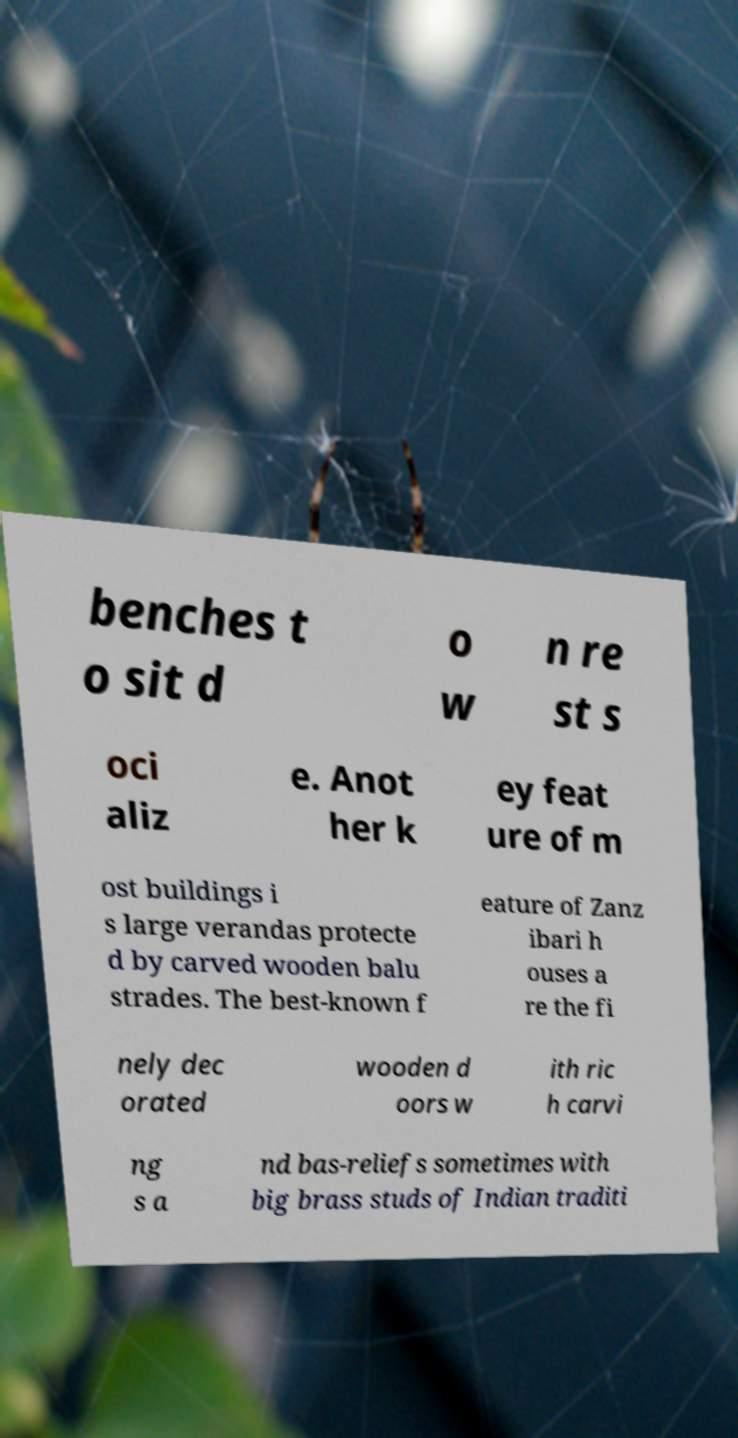For documentation purposes, I need the text within this image transcribed. Could you provide that? benches t o sit d o w n re st s oci aliz e. Anot her k ey feat ure of m ost buildings i s large verandas protecte d by carved wooden balu strades. The best-known f eature of Zanz ibari h ouses a re the fi nely dec orated wooden d oors w ith ric h carvi ng s a nd bas-reliefs sometimes with big brass studs of Indian traditi 